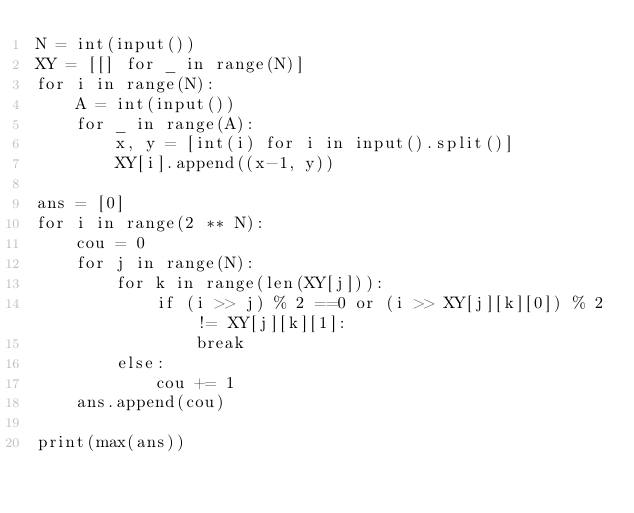<code> <loc_0><loc_0><loc_500><loc_500><_Python_>N = int(input())
XY = [[] for _ in range(N)]
for i in range(N):
    A = int(input())
    for _ in range(A):
        x, y = [int(i) for i in input().split()]
        XY[i].append((x-1, y))
     
ans = [0]
for i in range(2 ** N):
    cou = 0
    for j in range(N):
        for k in range(len(XY[j])):
            if (i >> j) % 2 ==0 or (i >> XY[j][k][0]) % 2 != XY[j][k][1]:
                break
        else:
            cou += 1
    ans.append(cou)
    
print(max(ans))</code> 